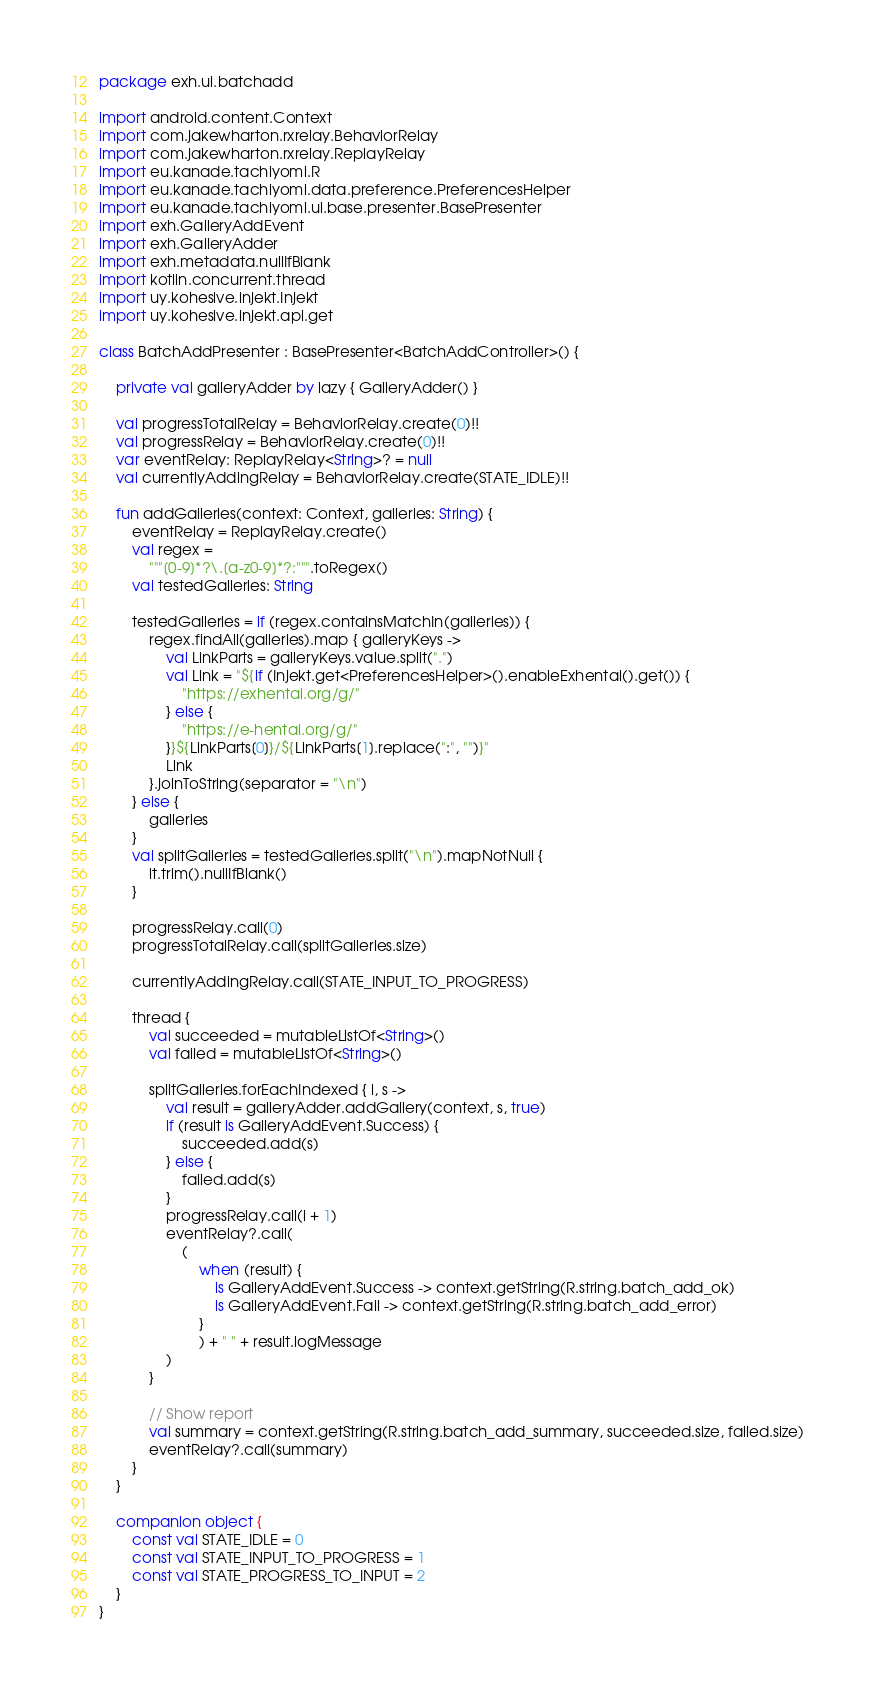<code> <loc_0><loc_0><loc_500><loc_500><_Kotlin_>package exh.ui.batchadd

import android.content.Context
import com.jakewharton.rxrelay.BehaviorRelay
import com.jakewharton.rxrelay.ReplayRelay
import eu.kanade.tachiyomi.R
import eu.kanade.tachiyomi.data.preference.PreferencesHelper
import eu.kanade.tachiyomi.ui.base.presenter.BasePresenter
import exh.GalleryAddEvent
import exh.GalleryAdder
import exh.metadata.nullIfBlank
import kotlin.concurrent.thread
import uy.kohesive.injekt.Injekt
import uy.kohesive.injekt.api.get

class BatchAddPresenter : BasePresenter<BatchAddController>() {

    private val galleryAdder by lazy { GalleryAdder() }

    val progressTotalRelay = BehaviorRelay.create(0)!!
    val progressRelay = BehaviorRelay.create(0)!!
    var eventRelay: ReplayRelay<String>? = null
    val currentlyAddingRelay = BehaviorRelay.create(STATE_IDLE)!!

    fun addGalleries(context: Context, galleries: String) {
        eventRelay = ReplayRelay.create()
        val regex =
            """[0-9]*?\.[a-z0-9]*?:""".toRegex()
        val testedGalleries: String

        testedGalleries = if (regex.containsMatchIn(galleries)) {
            regex.findAll(galleries).map { galleryKeys ->
                val LinkParts = galleryKeys.value.split(".")
                val Link = "${if (Injekt.get<PreferencesHelper>().enableExhentai().get()) {
                    "https://exhentai.org/g/"
                } else {
                    "https://e-hentai.org/g/"
                }}${LinkParts[0]}/${LinkParts[1].replace(":", "")}"
                Link
            }.joinToString(separator = "\n")
        } else {
            galleries
        }
        val splitGalleries = testedGalleries.split("\n").mapNotNull {
            it.trim().nullIfBlank()
        }

        progressRelay.call(0)
        progressTotalRelay.call(splitGalleries.size)

        currentlyAddingRelay.call(STATE_INPUT_TO_PROGRESS)

        thread {
            val succeeded = mutableListOf<String>()
            val failed = mutableListOf<String>()

            splitGalleries.forEachIndexed { i, s ->
                val result = galleryAdder.addGallery(context, s, true)
                if (result is GalleryAddEvent.Success) {
                    succeeded.add(s)
                } else {
                    failed.add(s)
                }
                progressRelay.call(i + 1)
                eventRelay?.call(
                    (
                        when (result) {
                            is GalleryAddEvent.Success -> context.getString(R.string.batch_add_ok)
                            is GalleryAddEvent.Fail -> context.getString(R.string.batch_add_error)
                        }
                        ) + " " + result.logMessage
                )
            }

            // Show report
            val summary = context.getString(R.string.batch_add_summary, succeeded.size, failed.size)
            eventRelay?.call(summary)
        }
    }

    companion object {
        const val STATE_IDLE = 0
        const val STATE_INPUT_TO_PROGRESS = 1
        const val STATE_PROGRESS_TO_INPUT = 2
    }
}
</code> 